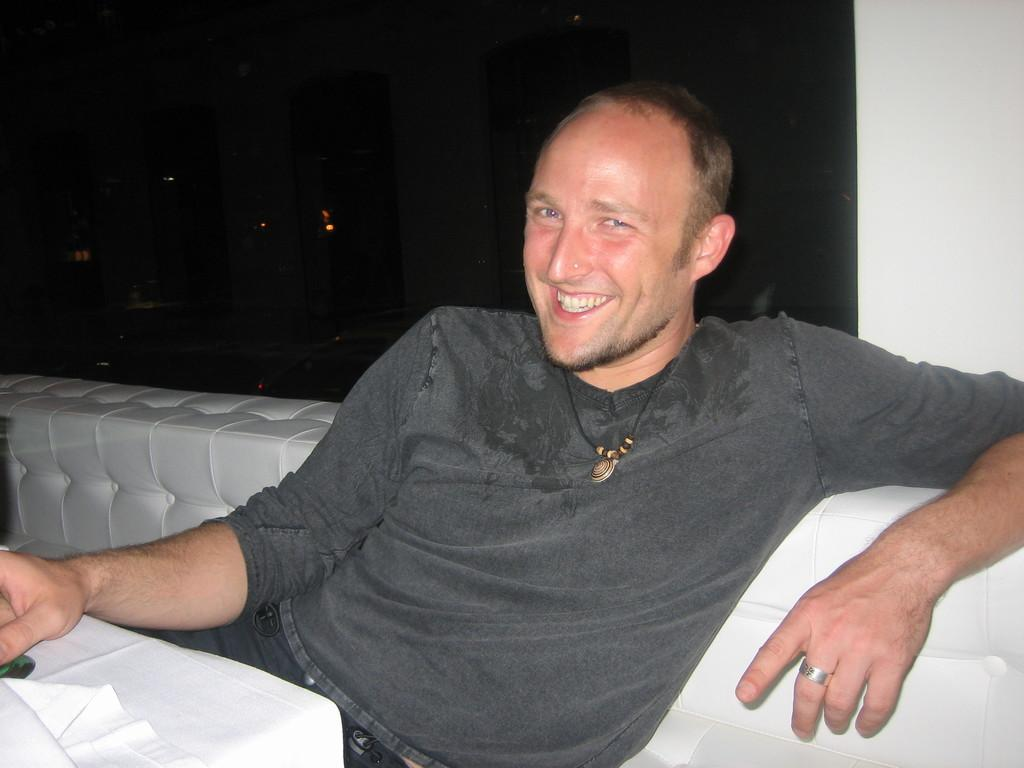What is the man doing in the image? The man is sitting on a sofa. What is in front of the man? There is a table in front of the man. What can be seen in the background of the image? There is a wall in the background. What type of clock is hanging on the wall behind the man? There is no clock visible in the image; only a wall can be seen in the background. 